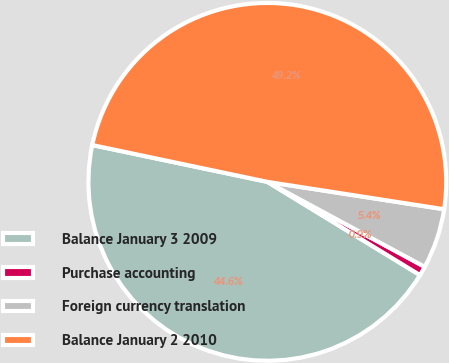Convert chart to OTSL. <chart><loc_0><loc_0><loc_500><loc_500><pie_chart><fcel>Balance January 3 2009<fcel>Purchase accounting<fcel>Foreign currency translation<fcel>Balance January 2 2010<nl><fcel>44.57%<fcel>0.85%<fcel>5.43%<fcel>49.15%<nl></chart> 